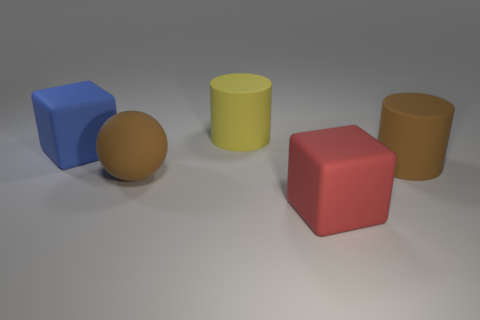What number of big matte objects have the same color as the large sphere?
Make the answer very short. 1. There is a large thing that is right of the red thing; does it have the same color as the big sphere that is to the right of the blue cube?
Ensure brevity in your answer.  Yes. Is there a brown thing of the same size as the red object?
Your response must be concise. Yes. The block that is right of the big blue matte thing is what color?
Give a very brief answer. Red. What shape is the big object that is left of the big yellow rubber cylinder and behind the big matte sphere?
Your answer should be very brief. Cube. What number of other big matte things are the same shape as the yellow rubber object?
Your answer should be very brief. 1. What number of large green metal things are there?
Provide a succinct answer. 0. There is a blue matte object that is the same size as the brown rubber cylinder; what is its shape?
Your answer should be very brief. Cube. There is a matte cylinder that is behind the brown rubber cylinder; are there any big rubber balls to the right of it?
Your answer should be very brief. No. What is the color of the other large rubber thing that is the same shape as the big yellow object?
Your answer should be compact. Brown. 